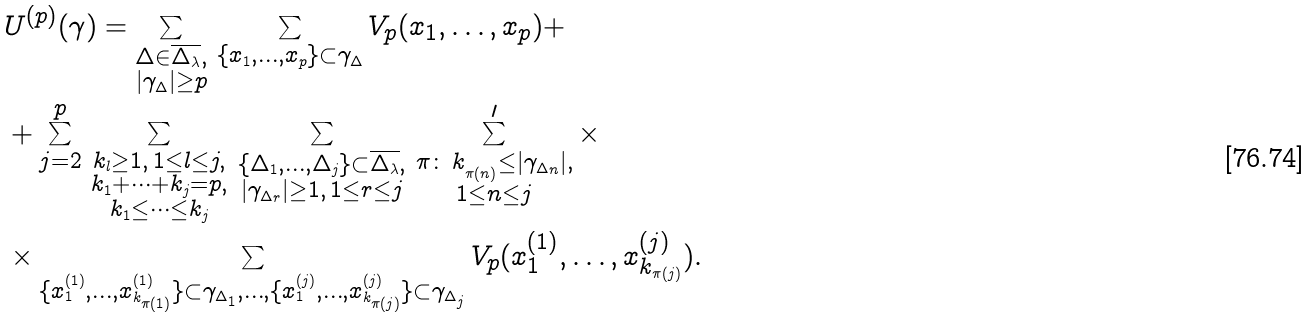Convert formula to latex. <formula><loc_0><loc_0><loc_500><loc_500>& U ^ { ( p ) } ( \gamma ) = \sum _ { \substack { \Delta \in \overline { \Delta _ { \lambda } } , \\ | \gamma _ { \Delta } | \geq p } } \, \sum _ { \{ x _ { 1 } , \dots , x _ { p } \} \subset \gamma _ { \Delta } } V _ { p } ( x _ { 1 } , \dots , x _ { p } ) + \\ & + \sum _ { j = 2 } ^ { p } \, \sum _ { \substack { k _ { l } \geq 1 , \, 1 \leq l \leq j , \\ k _ { 1 } + \cdots + k _ { j } = p , \\ k _ { 1 } \leq \dots \leq k _ { j } } } \, \sum _ { \substack { \{ \Delta _ { 1 } , \dots , \Delta _ { j } \} \subset \overline { \Delta _ { \lambda } } , \\ | \gamma _ { \Delta _ { r } } | \geq 1 , \, 1 \leq r \leq j } } \, \sum ^ { \prime } _ { \substack { \pi \colon \, k _ { _ { \pi ( n ) } } \leq | \gamma _ { \Delta _ { n } } | , \\ 1 \leq n \leq j } } \times \\ & \times \sum _ { \{ x _ { 1 } ^ { ( 1 ) } , \dots , x _ { k _ { \pi ( 1 ) } } ^ { ( 1 ) } \} \subset \gamma _ { \Delta _ { 1 } } , \dots , \{ x _ { 1 } ^ { ( j ) } , \dots , x _ { k _ { \pi ( j ) } } ^ { ( j ) } \} \subset \gamma _ { \Delta _ { j } } } V _ { p } ( x _ { 1 } ^ { ( 1 ) } , \dots , x _ { k _ { \pi ( j ) } } ^ { ( j ) } ) .</formula> 